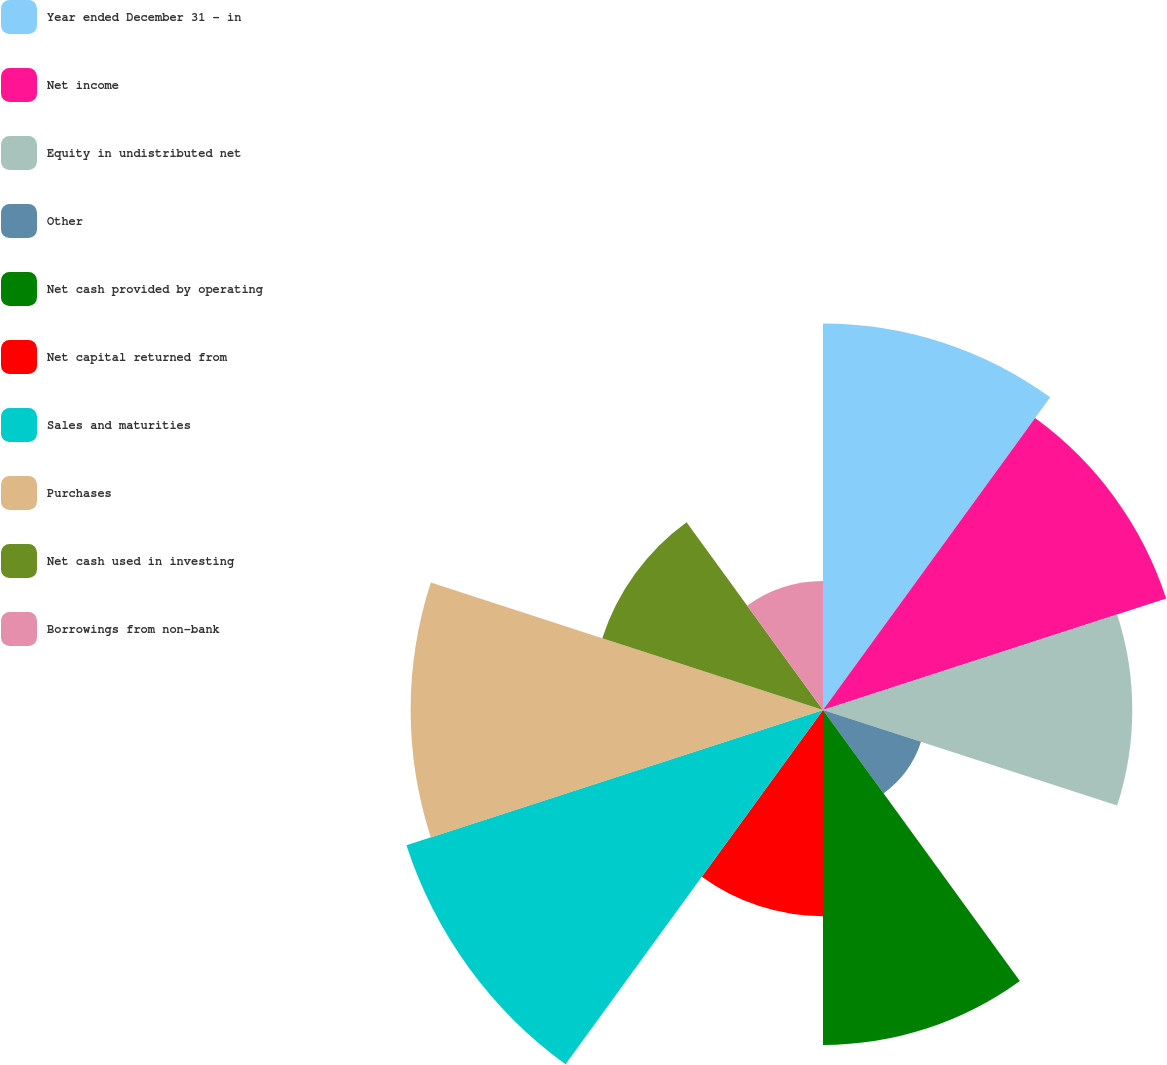Convert chart. <chart><loc_0><loc_0><loc_500><loc_500><pie_chart><fcel>Year ended December 31 - in<fcel>Net income<fcel>Equity in undistributed net<fcel>Other<fcel>Net cash provided by operating<fcel>Net capital returned from<fcel>Sales and maturities<fcel>Purchases<fcel>Net cash used in investing<fcel>Borrowings from non-bank<nl><fcel>13.27%<fcel>12.39%<fcel>10.62%<fcel>3.54%<fcel>11.5%<fcel>7.08%<fcel>15.04%<fcel>14.16%<fcel>7.97%<fcel>4.43%<nl></chart> 